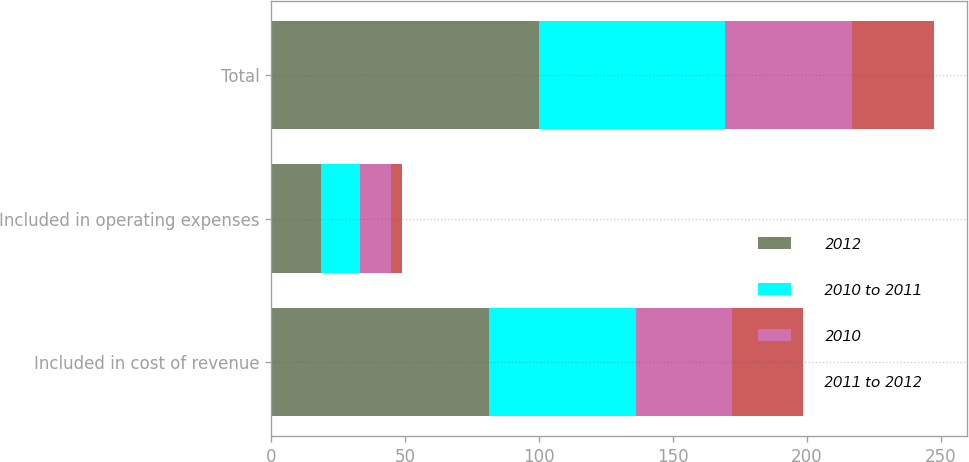Convert chart. <chart><loc_0><loc_0><loc_500><loc_500><stacked_bar_chart><ecel><fcel>Included in cost of revenue<fcel>Included in operating expenses<fcel>Total<nl><fcel>2012<fcel>81.3<fcel>18.6<fcel>99.9<nl><fcel>2010 to 2011<fcel>54.8<fcel>14.6<fcel>69.4<nl><fcel>2010<fcel>36.1<fcel>11.6<fcel>47.7<nl><fcel>2011 to 2012<fcel>26.5<fcel>4<fcel>30.5<nl></chart> 